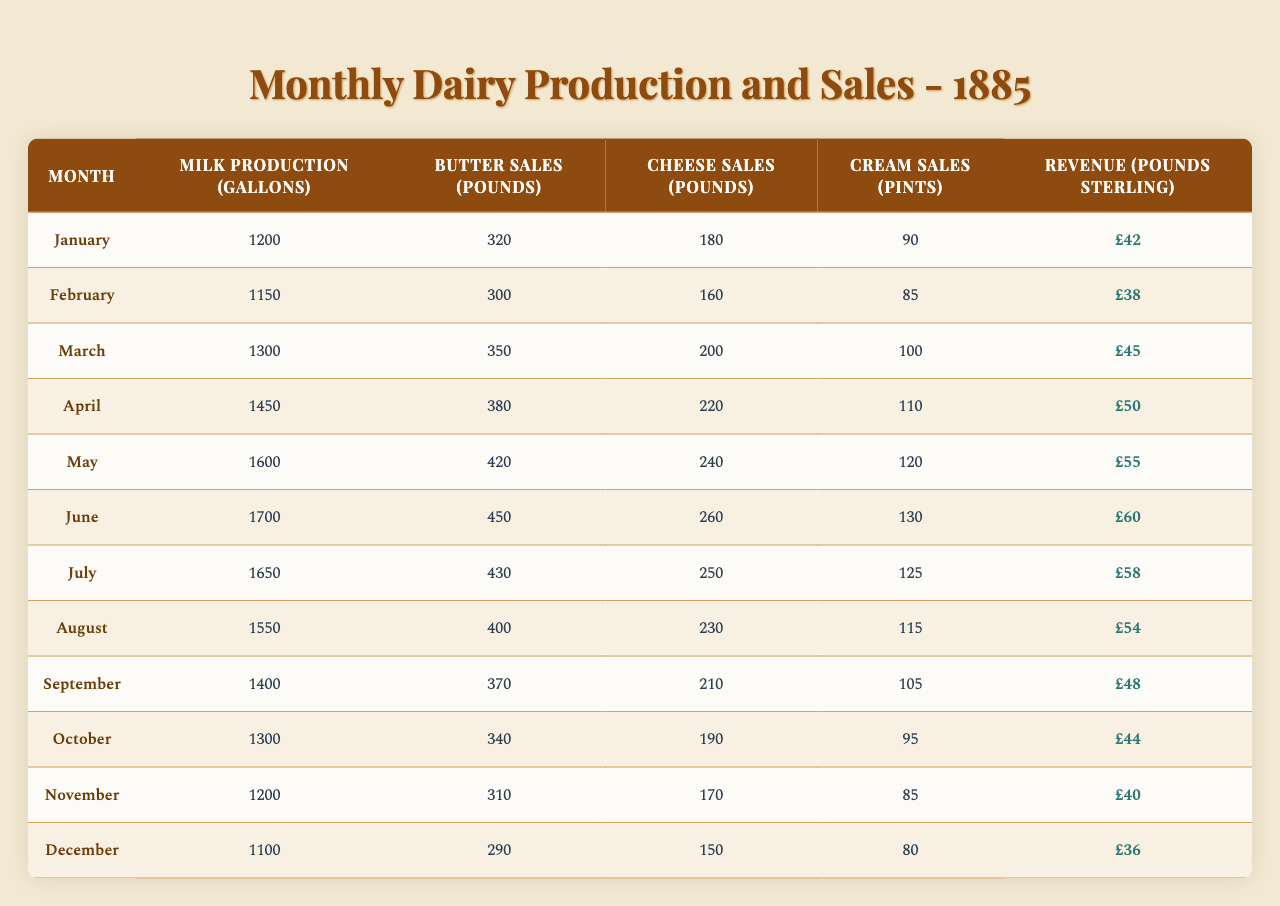What was the highest milk production recorded in a month? By examining the 'Milk Production (Gallons)' column, the maximum value found is 1700 gallons, which corresponds to June.
Answer: 1700 gallons In which month did the sales of cream reach their peak? Looking at the 'Cream Sales (Pints)' column, the highest value is 130 pints, which occurs in June.
Answer: June How many pounds of butter were sold in March? Referring to the 'Butter Sales (Pounds)' column, the value for March is 350 pounds.
Answer: 350 pounds What is the total revenue generated from dairy product sales in May? The revenue for May is listed as 55 pounds sterling in the 'Revenue (Pounds Sterling)' column.
Answer: £55 Which month had the lowest cheese sales? The 'Cheese Sales (Pounds)' column shows that cheese sales were lowest in December with 150 pounds.
Answer: December What was the average milk production across the year 1885? To find the average, sum the monthly production values (1200 + 1150 + 1300 + 1450 + 1600 + 1700 + 1650 + 1550 + 1400 + 1300 + 1200 + 1100) = 18,600 gallons, then divide by 12 months: 18,600 / 12 = 1550 gallons.
Answer: 1550 gallons Did butter sales exceed 400 pounds in any month? By checking the 'Butter Sales (Pounds)' column, the highest recorded is 450 pounds in June, which is greater than 400.
Answer: Yes What is the difference in revenue between the highest and lowest months? The highest revenue is £60 in June, and the lowest is £36 in December. The difference is 60 - 36 = 24 pounds sterling.
Answer: £24 How many pints of cream were sold in September? The 'Cream Sales (Pints)' column shows that in September, 105 pints of cream were sold.
Answer: 105 pints Which surface corresponds to the greatest product variety in terms of sales? Analyzing the data in 'Butter Sales', 'Cheese Sales', and 'Cream Sales', May has the highest variety in sales with 420 pounds of butter, 240 pounds of cheese, and 120 pints of cream.
Answer: May 